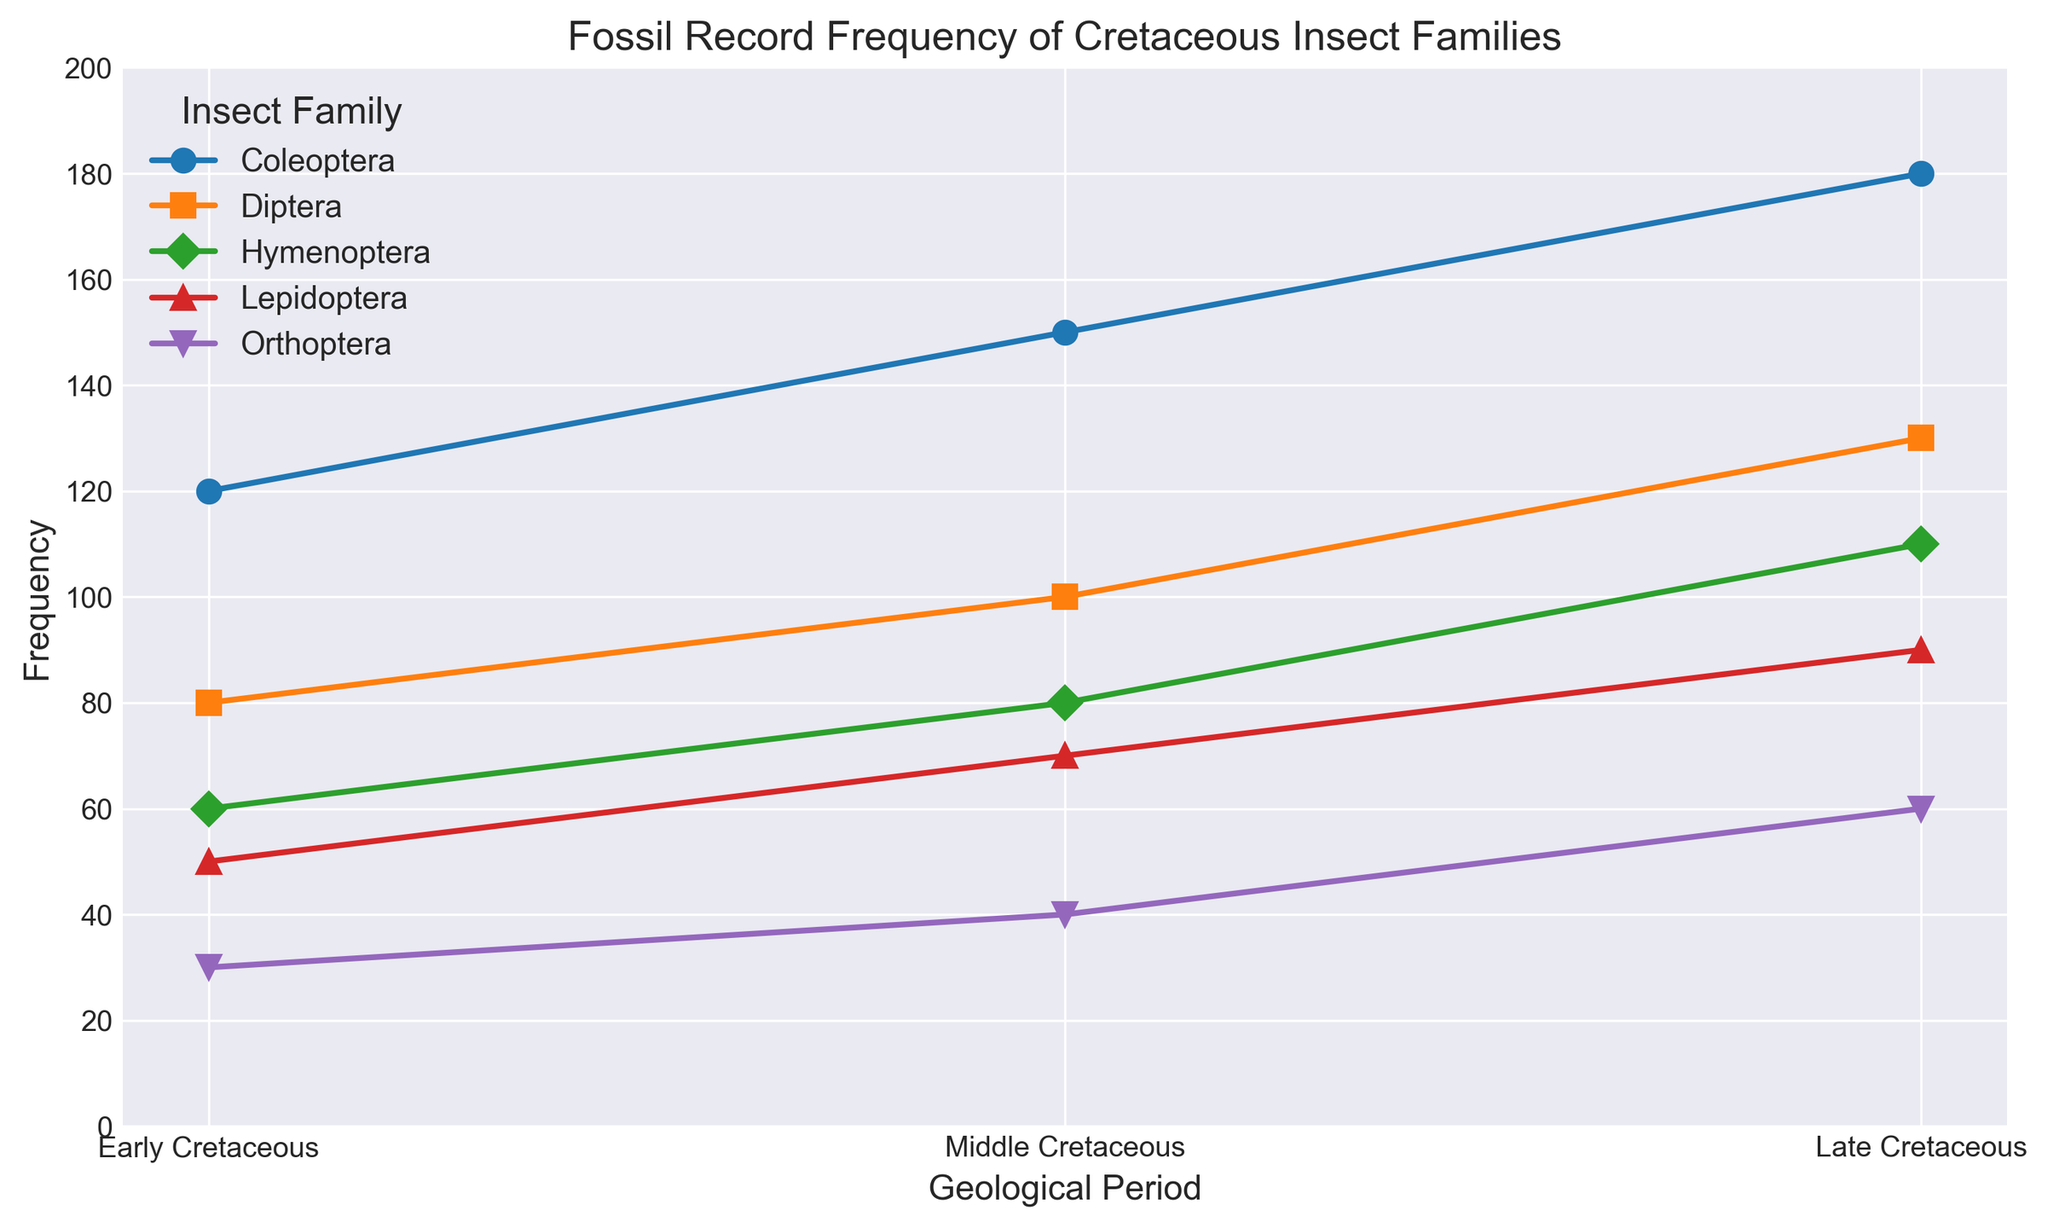Which insect family had the highest fossil frequency in the Late Cretaceous? By looking at the line representing the Late Cretaceous data points, identify the family with the peak value. The Coleoptera line peaks at the highest frequency, which is 180.
Answer: Coleoptera Which insect family experienced the greatest increase in fossil frequency from the Early Cretaceous to the Late Cretaceous? First, subtract the Early Cretaceous frequency from the Late Cretaceous frequency for each family: Coleoptera (180-120=60), Diptera (130-80=50), Hymenoptera (110-60=50), Lepidoptera (90-50=40), Orthoptera (60-30=30). Coleoptera has the greatest increase (60).
Answer: Coleoptera What is the total fossil frequency of Diptera across all the Cretaceous periods? Add up the frequencies of Diptera for Early (80), Middle (100), and Late (130) Cretaceous: 80 + 100 + 130 = 310.
Answer: 310 Compare the fossil frequencies of Hymenoptera and Lepidoptera in the Middle Cretaceous. Which is higher and by how much? In the Middle Cretaceous, Hymenoptera has a frequency of 80 and Lepidoptera has 70. The difference is 80 - 70 = 10. Hymenoptera is higher by 10.
Answer: Hymenoptera by 10 Which insect family shows the smallest increase in fossil frequency from the Middle Cretaceous to the Late Cretaceous? Calculate the difference for each family: Coleoptera (180-150=30), Diptera (130-100=30), Hymenoptera (110-80=30), Lepidoptera (90-70=20), Orthoptera (60-40=20). Both Lepidoptera and Orthoptera show the smallest increase of 20.
Answer: Lepidoptera and Orthoptera What is the average frequency of Coleoptera fossils across all periods? Add up the frequencies for Coleoptera: 120 (Early) + 150 (Middle) + 180 (Late) = 450. Then divide by the number of periods (3): 450/3 = 150.
Answer: 150 Which family showed a higher frequency in the Early Cretaceous, Lepidoptera or Orthoptera, and by how much? In the Early Cretaceous, Lepidoptera has a frequency of 50 and Orthoptera has 30. The difference is 50 - 30 = 20. Lepidoptera has a higher frequency by 20.
Answer: Lepidoptera by 20 How does the frequency trend of Diptera from Early to Late Cretaceous compare to the trend of Hymenoptera? Both Diptera and Hymenoptera show an increasing trend from Early (80 Diptera, 60 Hymenoptera) to Late (130 Diptera, 110 Hymenoptera) Cretaceous. The frequency of Diptera increases by 50 (130-80), and Hymenoptera by 50 (110-60).
Answer: Both increase by 50 Which family has the lowest average frequency across the Cretaceous periods? Calculate the average for each family and compare: Coleoptera (450/3=150), Diptera (310/3≈103.33), Hymenoptera (250/3≈83.33), Lepidoptera (210/3≈70), Orthoptera (130/3≈43.33). Orthoptera has the lowest average frequency of approximately 43.33.
Answer: Orthoptera 